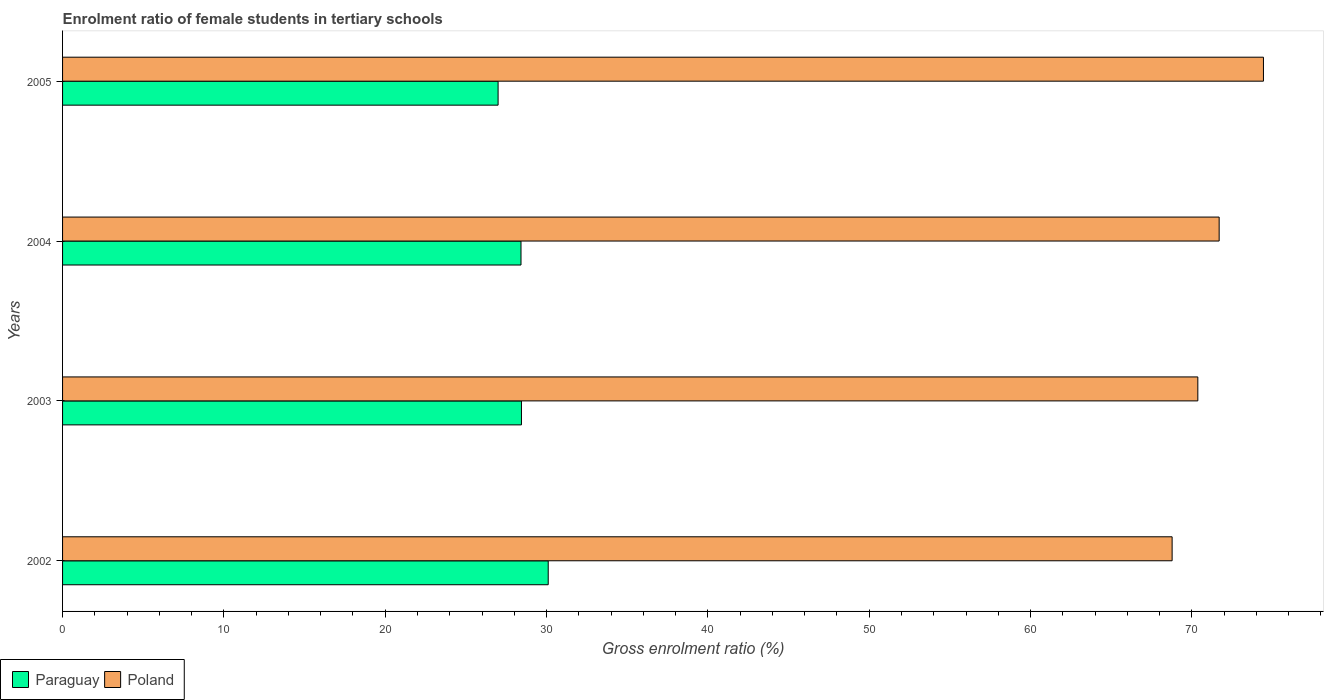How many different coloured bars are there?
Your answer should be compact. 2. How many groups of bars are there?
Offer a very short reply. 4. Are the number of bars per tick equal to the number of legend labels?
Provide a short and direct response. Yes. What is the label of the 3rd group of bars from the top?
Offer a terse response. 2003. What is the enrolment ratio of female students in tertiary schools in Poland in 2003?
Keep it short and to the point. 70.37. Across all years, what is the maximum enrolment ratio of female students in tertiary schools in Poland?
Offer a terse response. 74.43. Across all years, what is the minimum enrolment ratio of female students in tertiary schools in Paraguay?
Ensure brevity in your answer.  27. In which year was the enrolment ratio of female students in tertiary schools in Paraguay maximum?
Provide a succinct answer. 2002. What is the total enrolment ratio of female students in tertiary schools in Poland in the graph?
Ensure brevity in your answer.  285.27. What is the difference between the enrolment ratio of female students in tertiary schools in Paraguay in 2002 and that in 2005?
Provide a succinct answer. 3.11. What is the difference between the enrolment ratio of female students in tertiary schools in Poland in 2005 and the enrolment ratio of female students in tertiary schools in Paraguay in 2002?
Provide a short and direct response. 44.33. What is the average enrolment ratio of female students in tertiary schools in Paraguay per year?
Your response must be concise. 28.49. In the year 2004, what is the difference between the enrolment ratio of female students in tertiary schools in Poland and enrolment ratio of female students in tertiary schools in Paraguay?
Give a very brief answer. 43.27. In how many years, is the enrolment ratio of female students in tertiary schools in Paraguay greater than 54 %?
Your answer should be compact. 0. What is the ratio of the enrolment ratio of female students in tertiary schools in Paraguay in 2002 to that in 2004?
Provide a short and direct response. 1.06. Is the enrolment ratio of female students in tertiary schools in Paraguay in 2002 less than that in 2003?
Provide a succinct answer. No. Is the difference between the enrolment ratio of female students in tertiary schools in Poland in 2003 and 2004 greater than the difference between the enrolment ratio of female students in tertiary schools in Paraguay in 2003 and 2004?
Your answer should be very brief. No. What is the difference between the highest and the second highest enrolment ratio of female students in tertiary schools in Paraguay?
Offer a very short reply. 1.66. What is the difference between the highest and the lowest enrolment ratio of female students in tertiary schools in Paraguay?
Ensure brevity in your answer.  3.11. What does the 2nd bar from the top in 2003 represents?
Provide a short and direct response. Paraguay. Are all the bars in the graph horizontal?
Offer a very short reply. Yes. How many years are there in the graph?
Your response must be concise. 4. Are the values on the major ticks of X-axis written in scientific E-notation?
Your response must be concise. No. Does the graph contain any zero values?
Your answer should be compact. No. Does the graph contain grids?
Give a very brief answer. No. What is the title of the graph?
Your answer should be very brief. Enrolment ratio of female students in tertiary schools. Does "Europe(all income levels)" appear as one of the legend labels in the graph?
Offer a very short reply. No. What is the label or title of the X-axis?
Your answer should be compact. Gross enrolment ratio (%). What is the Gross enrolment ratio (%) in Paraguay in 2002?
Provide a succinct answer. 30.1. What is the Gross enrolment ratio (%) in Poland in 2002?
Offer a terse response. 68.77. What is the Gross enrolment ratio (%) in Paraguay in 2003?
Provide a succinct answer. 28.44. What is the Gross enrolment ratio (%) of Poland in 2003?
Offer a terse response. 70.37. What is the Gross enrolment ratio (%) of Paraguay in 2004?
Make the answer very short. 28.42. What is the Gross enrolment ratio (%) of Poland in 2004?
Your answer should be compact. 71.69. What is the Gross enrolment ratio (%) of Paraguay in 2005?
Your answer should be very brief. 27. What is the Gross enrolment ratio (%) of Poland in 2005?
Keep it short and to the point. 74.43. Across all years, what is the maximum Gross enrolment ratio (%) in Paraguay?
Your answer should be very brief. 30.1. Across all years, what is the maximum Gross enrolment ratio (%) in Poland?
Keep it short and to the point. 74.43. Across all years, what is the minimum Gross enrolment ratio (%) of Paraguay?
Your answer should be very brief. 27. Across all years, what is the minimum Gross enrolment ratio (%) of Poland?
Your response must be concise. 68.77. What is the total Gross enrolment ratio (%) in Paraguay in the graph?
Give a very brief answer. 113.96. What is the total Gross enrolment ratio (%) of Poland in the graph?
Offer a very short reply. 285.27. What is the difference between the Gross enrolment ratio (%) in Paraguay in 2002 and that in 2003?
Provide a succinct answer. 1.66. What is the difference between the Gross enrolment ratio (%) in Poland in 2002 and that in 2003?
Provide a short and direct response. -1.59. What is the difference between the Gross enrolment ratio (%) in Paraguay in 2002 and that in 2004?
Your answer should be very brief. 1.69. What is the difference between the Gross enrolment ratio (%) of Poland in 2002 and that in 2004?
Your response must be concise. -2.92. What is the difference between the Gross enrolment ratio (%) in Paraguay in 2002 and that in 2005?
Your answer should be very brief. 3.11. What is the difference between the Gross enrolment ratio (%) in Poland in 2002 and that in 2005?
Keep it short and to the point. -5.66. What is the difference between the Gross enrolment ratio (%) in Paraguay in 2003 and that in 2004?
Offer a terse response. 0.03. What is the difference between the Gross enrolment ratio (%) in Poland in 2003 and that in 2004?
Your answer should be very brief. -1.32. What is the difference between the Gross enrolment ratio (%) in Paraguay in 2003 and that in 2005?
Make the answer very short. 1.45. What is the difference between the Gross enrolment ratio (%) in Poland in 2003 and that in 2005?
Offer a very short reply. -4.07. What is the difference between the Gross enrolment ratio (%) of Paraguay in 2004 and that in 2005?
Your answer should be very brief. 1.42. What is the difference between the Gross enrolment ratio (%) in Poland in 2004 and that in 2005?
Keep it short and to the point. -2.75. What is the difference between the Gross enrolment ratio (%) of Paraguay in 2002 and the Gross enrolment ratio (%) of Poland in 2003?
Ensure brevity in your answer.  -40.27. What is the difference between the Gross enrolment ratio (%) in Paraguay in 2002 and the Gross enrolment ratio (%) in Poland in 2004?
Offer a very short reply. -41.59. What is the difference between the Gross enrolment ratio (%) in Paraguay in 2002 and the Gross enrolment ratio (%) in Poland in 2005?
Keep it short and to the point. -44.33. What is the difference between the Gross enrolment ratio (%) of Paraguay in 2003 and the Gross enrolment ratio (%) of Poland in 2004?
Offer a terse response. -43.25. What is the difference between the Gross enrolment ratio (%) of Paraguay in 2003 and the Gross enrolment ratio (%) of Poland in 2005?
Your response must be concise. -45.99. What is the difference between the Gross enrolment ratio (%) of Paraguay in 2004 and the Gross enrolment ratio (%) of Poland in 2005?
Provide a short and direct response. -46.02. What is the average Gross enrolment ratio (%) of Paraguay per year?
Your answer should be compact. 28.49. What is the average Gross enrolment ratio (%) in Poland per year?
Your answer should be very brief. 71.32. In the year 2002, what is the difference between the Gross enrolment ratio (%) of Paraguay and Gross enrolment ratio (%) of Poland?
Provide a short and direct response. -38.67. In the year 2003, what is the difference between the Gross enrolment ratio (%) in Paraguay and Gross enrolment ratio (%) in Poland?
Offer a very short reply. -41.92. In the year 2004, what is the difference between the Gross enrolment ratio (%) in Paraguay and Gross enrolment ratio (%) in Poland?
Your answer should be compact. -43.27. In the year 2005, what is the difference between the Gross enrolment ratio (%) of Paraguay and Gross enrolment ratio (%) of Poland?
Keep it short and to the point. -47.44. What is the ratio of the Gross enrolment ratio (%) in Paraguay in 2002 to that in 2003?
Give a very brief answer. 1.06. What is the ratio of the Gross enrolment ratio (%) in Poland in 2002 to that in 2003?
Give a very brief answer. 0.98. What is the ratio of the Gross enrolment ratio (%) of Paraguay in 2002 to that in 2004?
Keep it short and to the point. 1.06. What is the ratio of the Gross enrolment ratio (%) in Poland in 2002 to that in 2004?
Ensure brevity in your answer.  0.96. What is the ratio of the Gross enrolment ratio (%) in Paraguay in 2002 to that in 2005?
Provide a short and direct response. 1.12. What is the ratio of the Gross enrolment ratio (%) in Poland in 2002 to that in 2005?
Offer a terse response. 0.92. What is the ratio of the Gross enrolment ratio (%) in Paraguay in 2003 to that in 2004?
Offer a very short reply. 1. What is the ratio of the Gross enrolment ratio (%) of Poland in 2003 to that in 2004?
Provide a succinct answer. 0.98. What is the ratio of the Gross enrolment ratio (%) in Paraguay in 2003 to that in 2005?
Ensure brevity in your answer.  1.05. What is the ratio of the Gross enrolment ratio (%) in Poland in 2003 to that in 2005?
Your response must be concise. 0.95. What is the ratio of the Gross enrolment ratio (%) of Paraguay in 2004 to that in 2005?
Provide a short and direct response. 1.05. What is the ratio of the Gross enrolment ratio (%) in Poland in 2004 to that in 2005?
Ensure brevity in your answer.  0.96. What is the difference between the highest and the second highest Gross enrolment ratio (%) in Paraguay?
Offer a terse response. 1.66. What is the difference between the highest and the second highest Gross enrolment ratio (%) in Poland?
Offer a terse response. 2.75. What is the difference between the highest and the lowest Gross enrolment ratio (%) of Paraguay?
Offer a very short reply. 3.11. What is the difference between the highest and the lowest Gross enrolment ratio (%) in Poland?
Your response must be concise. 5.66. 